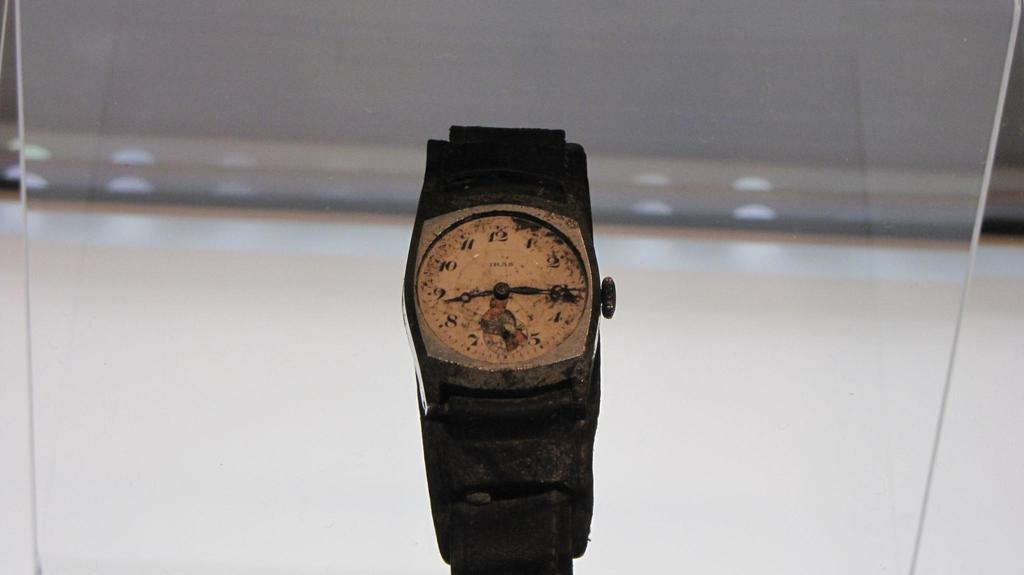Provide a one-sentence caption for the provided image. A very old wristwatch, with the brand name IRAS, sits in a display case. 